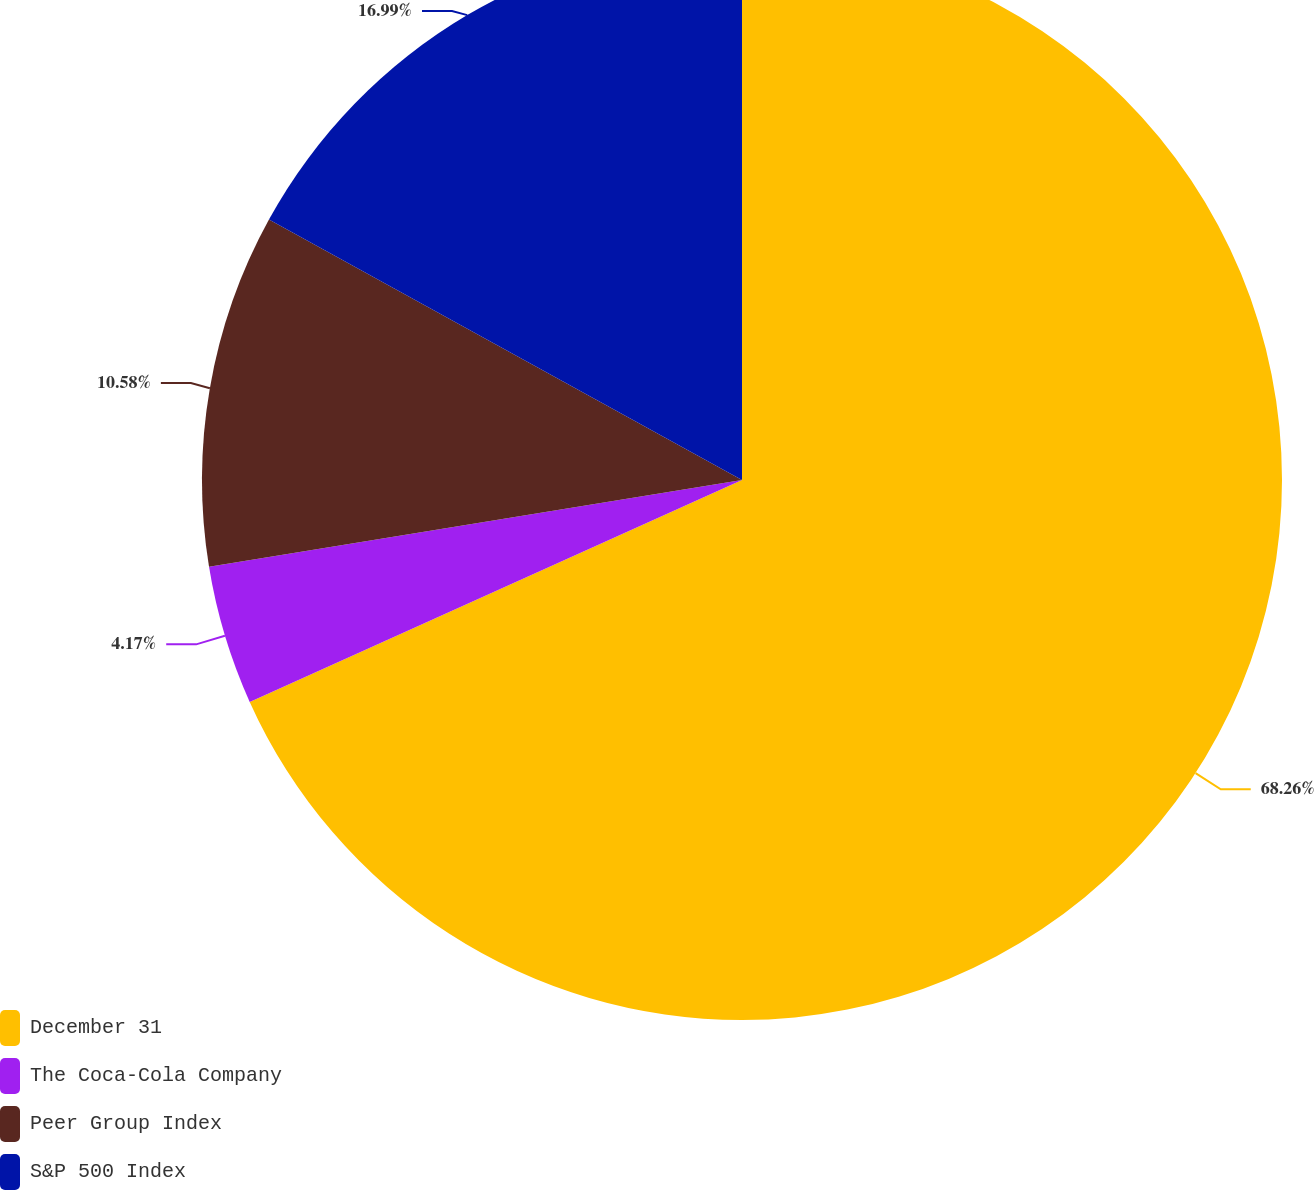<chart> <loc_0><loc_0><loc_500><loc_500><pie_chart><fcel>December 31<fcel>The Coca-Cola Company<fcel>Peer Group Index<fcel>S&P 500 Index<nl><fcel>68.26%<fcel>4.17%<fcel>10.58%<fcel>16.99%<nl></chart> 